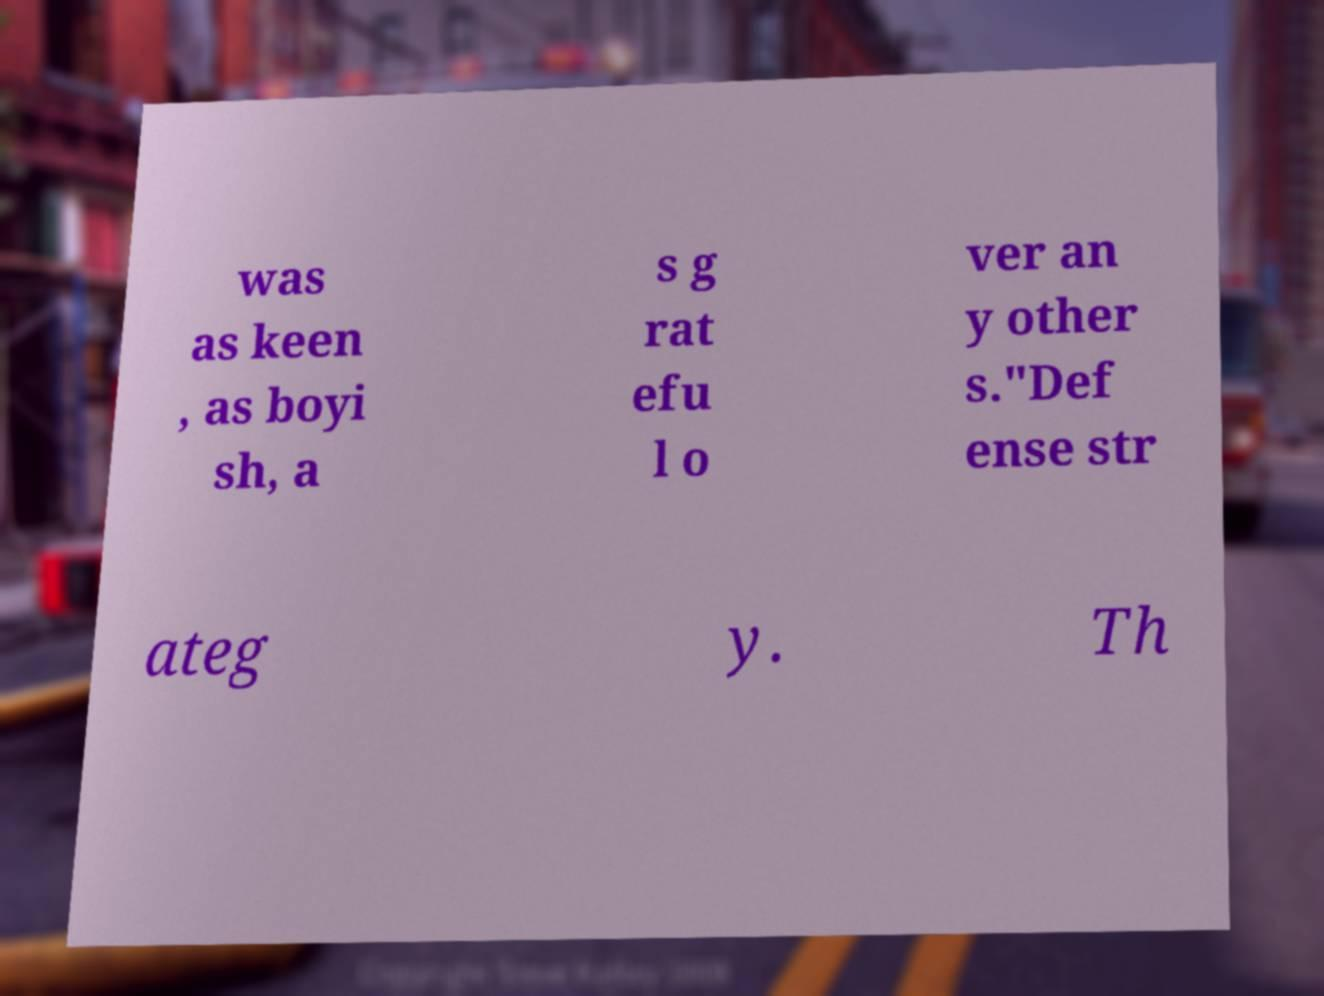What messages or text are displayed in this image? I need them in a readable, typed format. was as keen , as boyi sh, a s g rat efu l o ver an y other s."Def ense str ateg y. Th 